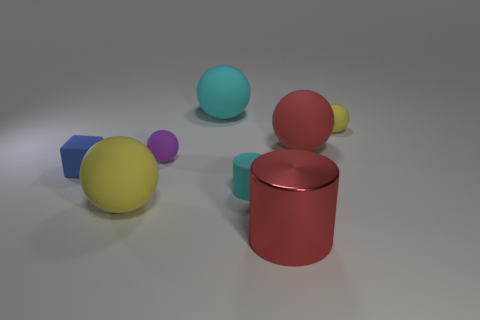What can you tell me about the lighting in the image? The image has a soft and diffuse lighting setup, producing gentle shadows on the ground beneath each object. There are no harsh shadows or highlights, indicating the light source is not extremely bright or direct. The lighting gives the scene a calm and somewhat neutral atmosphere. 